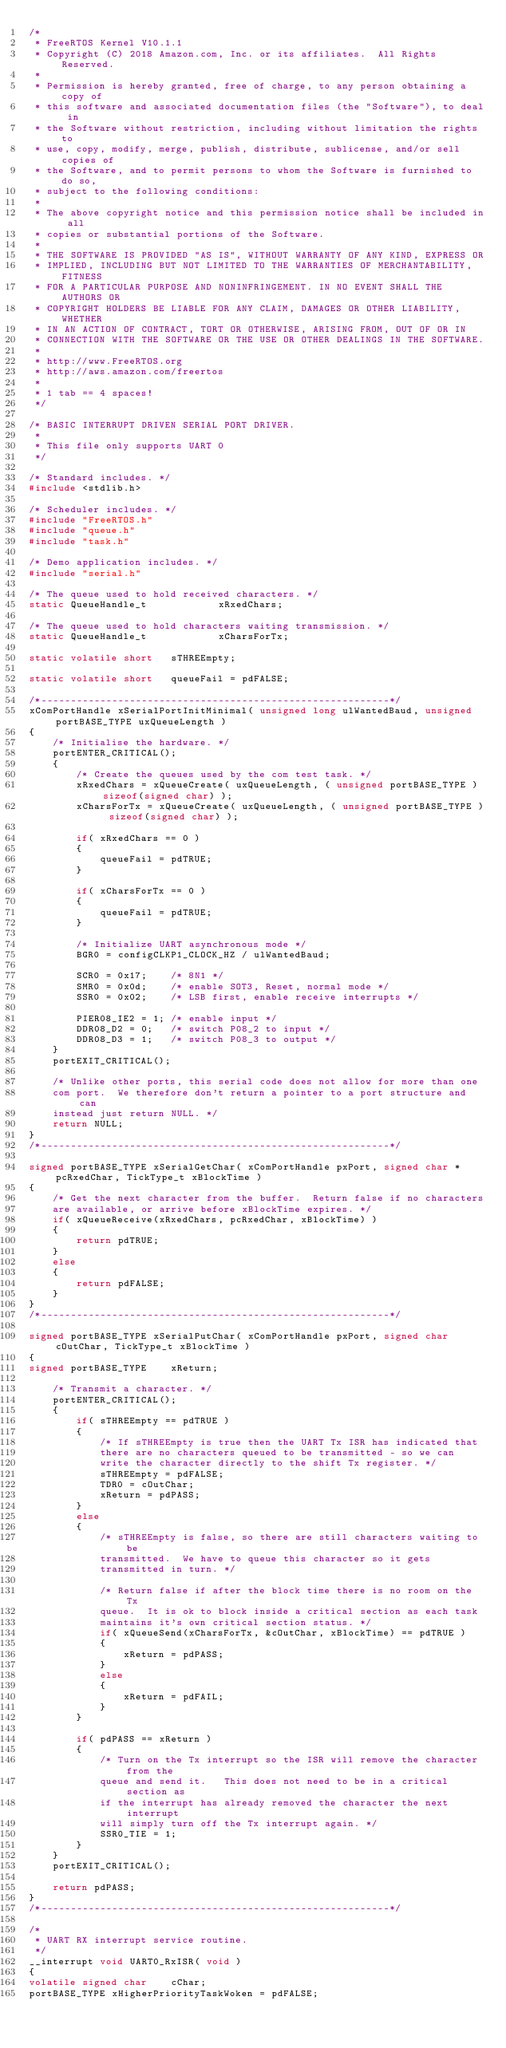<code> <loc_0><loc_0><loc_500><loc_500><_C_>/*
 * FreeRTOS Kernel V10.1.1
 * Copyright (C) 2018 Amazon.com, Inc. or its affiliates.  All Rights Reserved.
 *
 * Permission is hereby granted, free of charge, to any person obtaining a copy of
 * this software and associated documentation files (the "Software"), to deal in
 * the Software without restriction, including without limitation the rights to
 * use, copy, modify, merge, publish, distribute, sublicense, and/or sell copies of
 * the Software, and to permit persons to whom the Software is furnished to do so,
 * subject to the following conditions:
 *
 * The above copyright notice and this permission notice shall be included in all
 * copies or substantial portions of the Software.
 *
 * THE SOFTWARE IS PROVIDED "AS IS", WITHOUT WARRANTY OF ANY KIND, EXPRESS OR
 * IMPLIED, INCLUDING BUT NOT LIMITED TO THE WARRANTIES OF MERCHANTABILITY, FITNESS
 * FOR A PARTICULAR PURPOSE AND NONINFRINGEMENT. IN NO EVENT SHALL THE AUTHORS OR
 * COPYRIGHT HOLDERS BE LIABLE FOR ANY CLAIM, DAMAGES OR OTHER LIABILITY, WHETHER
 * IN AN ACTION OF CONTRACT, TORT OR OTHERWISE, ARISING FROM, OUT OF OR IN
 * CONNECTION WITH THE SOFTWARE OR THE USE OR OTHER DEALINGS IN THE SOFTWARE.
 *
 * http://www.FreeRTOS.org
 * http://aws.amazon.com/freertos
 *
 * 1 tab == 4 spaces!
 */

/* BASIC INTERRUPT DRIVEN SERIAL PORT DRIVER.   
 * 
 * This file only supports UART 0
 */

/* Standard includes. */
#include <stdlib.h>

/* Scheduler includes. */
#include "FreeRTOS.h"
#include "queue.h"
#include "task.h"

/* Demo application includes. */
#include "serial.h"

/* The queue used to hold received characters. */
static QueueHandle_t			xRxedChars;

/* The queue used to hold characters waiting transmission. */
static QueueHandle_t			xCharsForTx;

static volatile short	sTHREEmpty;

static volatile short	queueFail = pdFALSE;

/*-----------------------------------------------------------*/
xComPortHandle xSerialPortInitMinimal( unsigned long ulWantedBaud, unsigned portBASE_TYPE uxQueueLength )
{
	/* Initialise the hardware. */
	portENTER_CRITICAL();
	{
		/* Create the queues used by the com test task. */
		xRxedChars = xQueueCreate( uxQueueLength, ( unsigned portBASE_TYPE ) sizeof(signed char) );
		xCharsForTx = xQueueCreate( uxQueueLength, ( unsigned portBASE_TYPE ) sizeof(signed char) );

		if( xRxedChars == 0 )
		{
			queueFail = pdTRUE;
		}

		if( xCharsForTx == 0 )
		{
			queueFail = pdTRUE;
		}

		/* Initialize UART asynchronous mode */
		BGR0 = configCLKP1_CLOCK_HZ / ulWantedBaud;

		SCR0 = 0x17;	/* 8N1 */
		SMR0 = 0x0d;	/* enable SOT3, Reset, normal mode */
		SSR0 = 0x02;	/* LSB first, enable receive interrupts */

		PIER08_IE2 = 1; /* enable input */
		DDR08_D2 = 0;	/* switch P08_2 to input */
		DDR08_D3 = 1;	/* switch P08_3 to output */
	}
	portEXIT_CRITICAL();

	/* Unlike other ports, this serial code does not allow for more than one
	com port.  We therefore don't return a pointer to a port structure and can
	instead just return NULL. */
	return NULL;
}
/*-----------------------------------------------------------*/

signed portBASE_TYPE xSerialGetChar( xComPortHandle pxPort, signed char *pcRxedChar, TickType_t xBlockTime )
{
	/* Get the next character from the buffer.  Return false if no characters
	are available, or arrive before xBlockTime expires. */
	if( xQueueReceive(xRxedChars, pcRxedChar, xBlockTime) )
	{
		return pdTRUE;
	}
	else
	{
		return pdFALSE;
	}
}
/*-----------------------------------------------------------*/

signed portBASE_TYPE xSerialPutChar( xComPortHandle pxPort, signed char cOutChar, TickType_t xBlockTime )
{
signed portBASE_TYPE	xReturn;

	/* Transmit a character. */
	portENTER_CRITICAL();
	{
		if( sTHREEmpty == pdTRUE )
		{
			/* If sTHREEmpty is true then the UART Tx ISR has indicated that 
			there are no characters queued to be transmitted - so we can
			write the character directly to the shift Tx register. */
			sTHREEmpty = pdFALSE;
			TDR0 = cOutChar;
			xReturn = pdPASS;
		}
		else
		{
			/* sTHREEmpty is false, so there are still characters waiting to be
			transmitted.  We have to queue this character so it gets 
			transmitted	in turn. */

			/* Return false if after the block time there is no room on the Tx 
			queue.  It is ok to block inside a critical section as each task
			maintains it's own critical section status. */
			if( xQueueSend(xCharsForTx, &cOutChar, xBlockTime) == pdTRUE )
			{
				xReturn = pdPASS;
			}
			else
			{
				xReturn = pdFAIL;
			}
		}

		if( pdPASS == xReturn )
		{
			/* Turn on the Tx interrupt so the ISR will remove the character from the
			queue and send it.   This does not need to be in a critical section as
			if the interrupt has already removed the character the next interrupt
			will simply turn off the Tx interrupt again. */
			SSR0_TIE = 1;
		}
	}
	portEXIT_CRITICAL();

	return pdPASS;
}
/*-----------------------------------------------------------*/

/*
 * UART RX interrupt service routine.
 */
__interrupt void UART0_RxISR( void )
{
volatile signed char	cChar;
portBASE_TYPE xHigherPriorityTaskWoken = pdFALSE;
</code> 